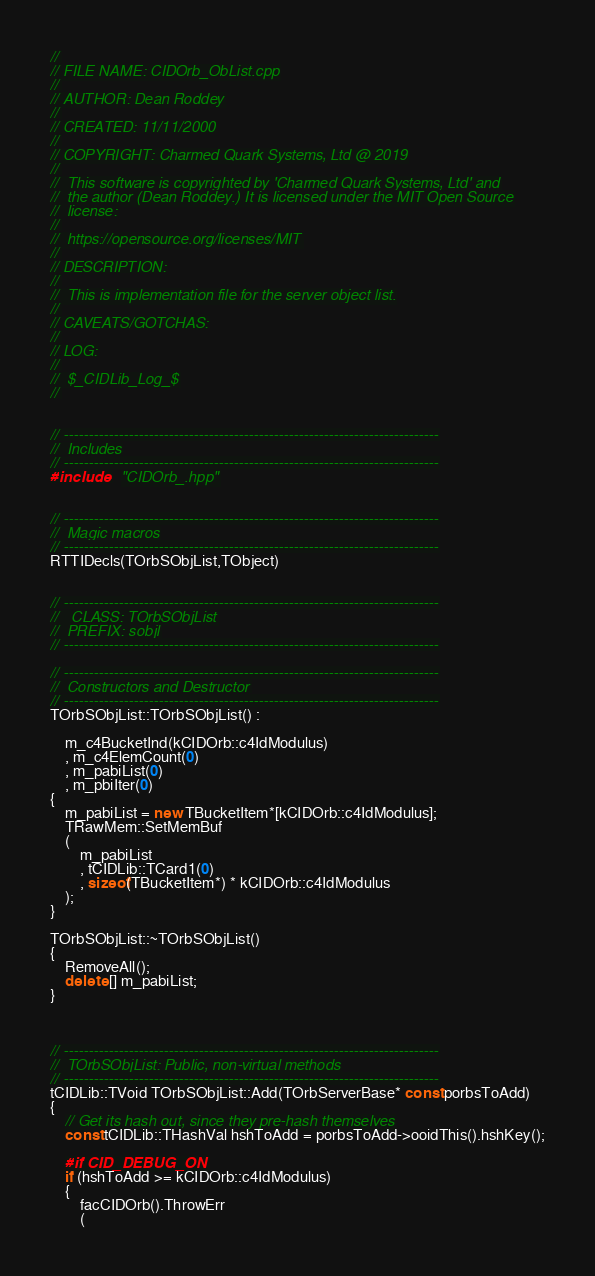<code> <loc_0><loc_0><loc_500><loc_500><_C++_>//
// FILE NAME: CIDOrb_ObList.cpp
//
// AUTHOR: Dean Roddey
//
// CREATED: 11/11/2000
//
// COPYRIGHT: Charmed Quark Systems, Ltd @ 2019
//
//  This software is copyrighted by 'Charmed Quark Systems, Ltd' and
//  the author (Dean Roddey.) It is licensed under the MIT Open Source
//  license:
//
//  https://opensource.org/licenses/MIT
//
// DESCRIPTION:
//
//  This is implementation file for the server object list.
//
// CAVEATS/GOTCHAS:
//
// LOG:
//
//  $_CIDLib_Log_$
//


// ---------------------------------------------------------------------------
//  Includes
// ---------------------------------------------------------------------------
#include    "CIDOrb_.hpp"


// ---------------------------------------------------------------------------
//  Magic macros
// ---------------------------------------------------------------------------
RTTIDecls(TOrbSObjList,TObject)


// ---------------------------------------------------------------------------
//   CLASS: TOrbSObjList
//  PREFIX: sobjl
// ---------------------------------------------------------------------------

// ---------------------------------------------------------------------------
//  Constructors and Destructor
// ---------------------------------------------------------------------------
TOrbSObjList::TOrbSObjList() :

    m_c4BucketInd(kCIDOrb::c4IdModulus)
    , m_c4ElemCount(0)
    , m_pabiList(0)
    , m_pbiIter(0)
{
    m_pabiList = new TBucketItem*[kCIDOrb::c4IdModulus];
    TRawMem::SetMemBuf
    (
        m_pabiList
        , tCIDLib::TCard1(0)
        , sizeof(TBucketItem*) * kCIDOrb::c4IdModulus
    );
}

TOrbSObjList::~TOrbSObjList()
{
    RemoveAll();
    delete [] m_pabiList;
}



// ---------------------------------------------------------------------------
//  TOrbSObjList: Public, non-virtual methods
// ---------------------------------------------------------------------------
tCIDLib::TVoid TOrbSObjList::Add(TOrbServerBase* const porbsToAdd)
{
    // Get its hash out, since they pre-hash themselves
    const tCIDLib::THashVal hshToAdd = porbsToAdd->ooidThis().hshKey();

    #if CID_DEBUG_ON
    if (hshToAdd >= kCIDOrb::c4IdModulus)
    {
        facCIDOrb().ThrowErr
        (</code> 